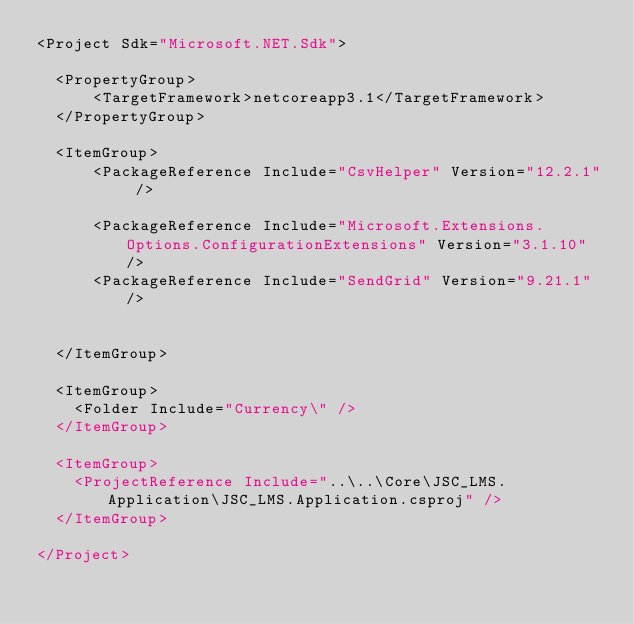<code> <loc_0><loc_0><loc_500><loc_500><_XML_><Project Sdk="Microsoft.NET.Sdk">

  <PropertyGroup>
	  <TargetFramework>netcoreapp3.1</TargetFramework>
  </PropertyGroup>

  <ItemGroup>
	  <PackageReference Include="CsvHelper" Version="12.2.1" />

	  <PackageReference Include="Microsoft.Extensions.Options.ConfigurationExtensions" Version="3.1.10" />
	  <PackageReference Include="SendGrid" Version="9.21.1" />


  </ItemGroup>

  <ItemGroup>
    <Folder Include="Currency\" />
  </ItemGroup>

  <ItemGroup>
    <ProjectReference Include="..\..\Core\JSC_LMS.Application\JSC_LMS.Application.csproj" />
  </ItemGroup>

</Project>
</code> 